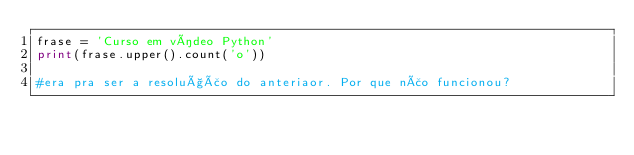<code> <loc_0><loc_0><loc_500><loc_500><_Python_>frase = 'Curso em vídeo Python'
print(frase.upper().count('o'))

#era pra ser a resolução do anteriaor. Por que não funcionou?</code> 